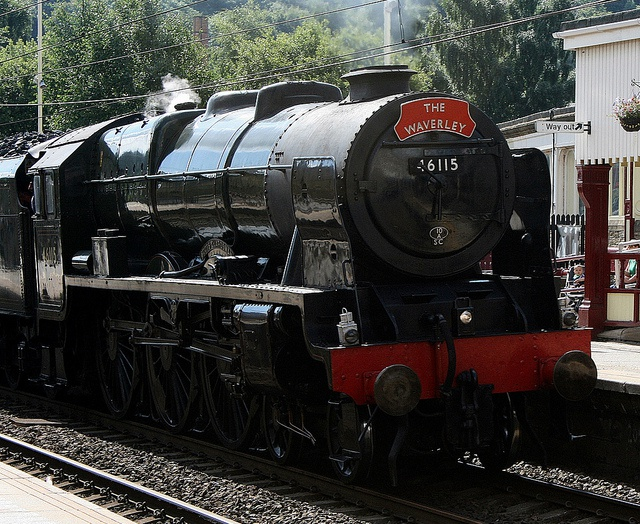Describe the objects in this image and their specific colors. I can see train in black, gray, lightgray, and maroon tones and potted plant in gray, black, lightgray, and darkgray tones in this image. 